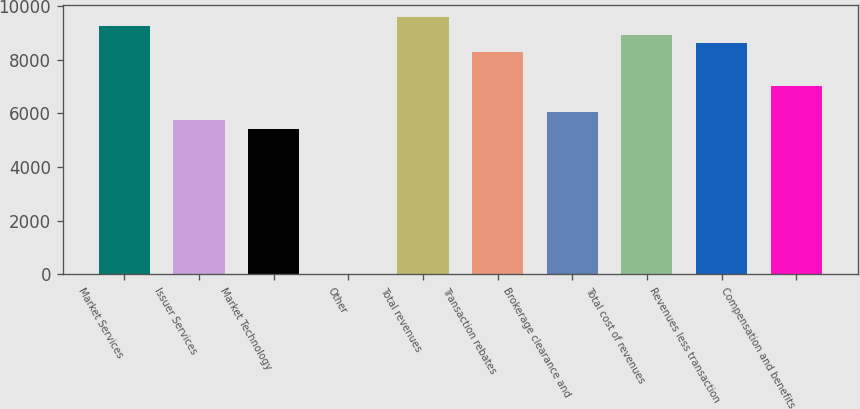<chart> <loc_0><loc_0><loc_500><loc_500><bar_chart><fcel>Market Services<fcel>Issuer Services<fcel>Market Technology<fcel>Other<fcel>Total revenues<fcel>Transaction rebates<fcel>Brokerage clearance and<fcel>Total cost of revenues<fcel>Revenues less transaction<fcel>Compensation and benefits<nl><fcel>9269.4<fcel>5753.8<fcel>5434.2<fcel>1<fcel>9589<fcel>8310.6<fcel>6073.4<fcel>8949.8<fcel>8630.2<fcel>7032.2<nl></chart> 